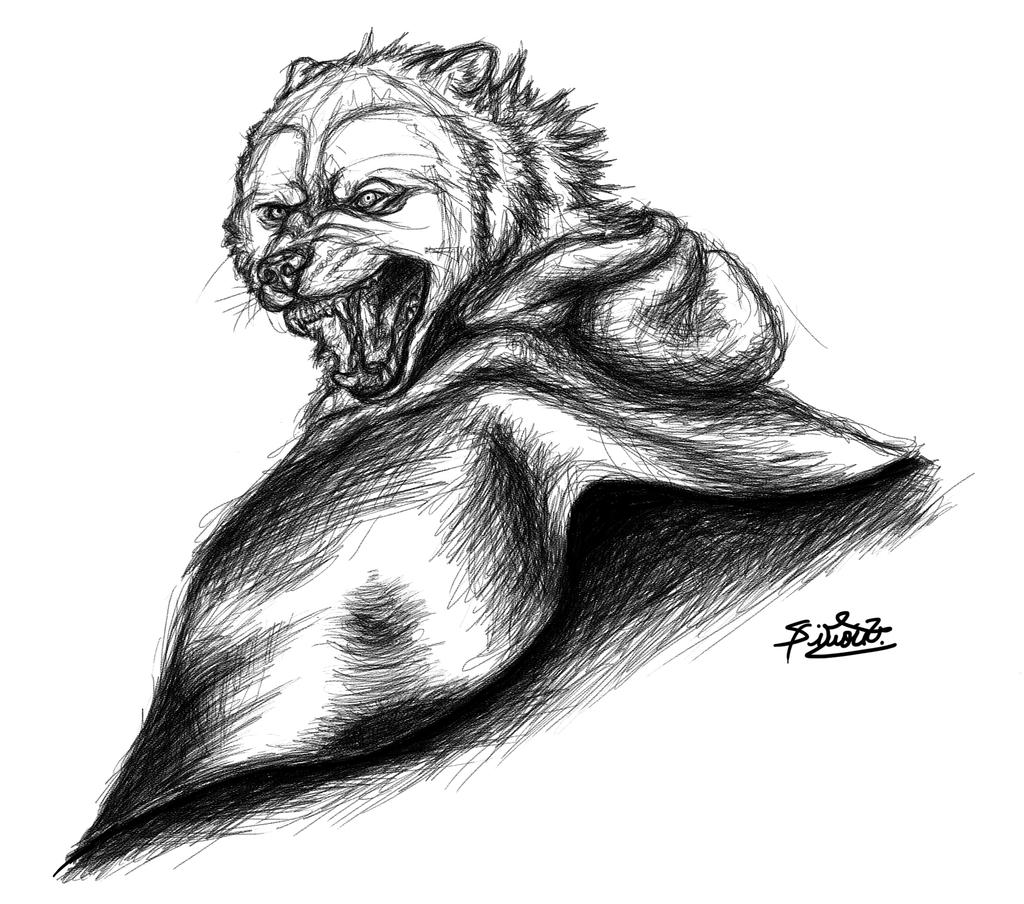What is depicted in the image? There is a drawing of an animal in the image. What else can be found in the image besides the drawing? There is text in the image. What type of cushion is being advertised in the image? There is no cushion or advertisement present in the image; it only contains a drawing of an animal and text. What is the plot of the story being told in the image? There is no story or plot depicted in the image; it only contains a drawing of an animal and text. 